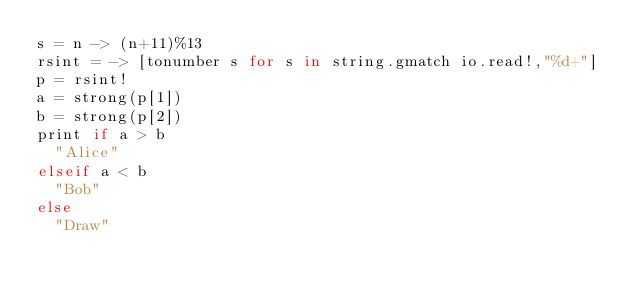Convert code to text. <code><loc_0><loc_0><loc_500><loc_500><_MoonScript_>s = n -> (n+11)%13
rsint = -> [tonumber s for s in string.gmatch io.read!,"%d+"]
p = rsint!
a = strong(p[1])
b = strong(p[2])
print if a > b
  "Alice"
elseif a < b
  "Bob"
else
  "Draw"
</code> 